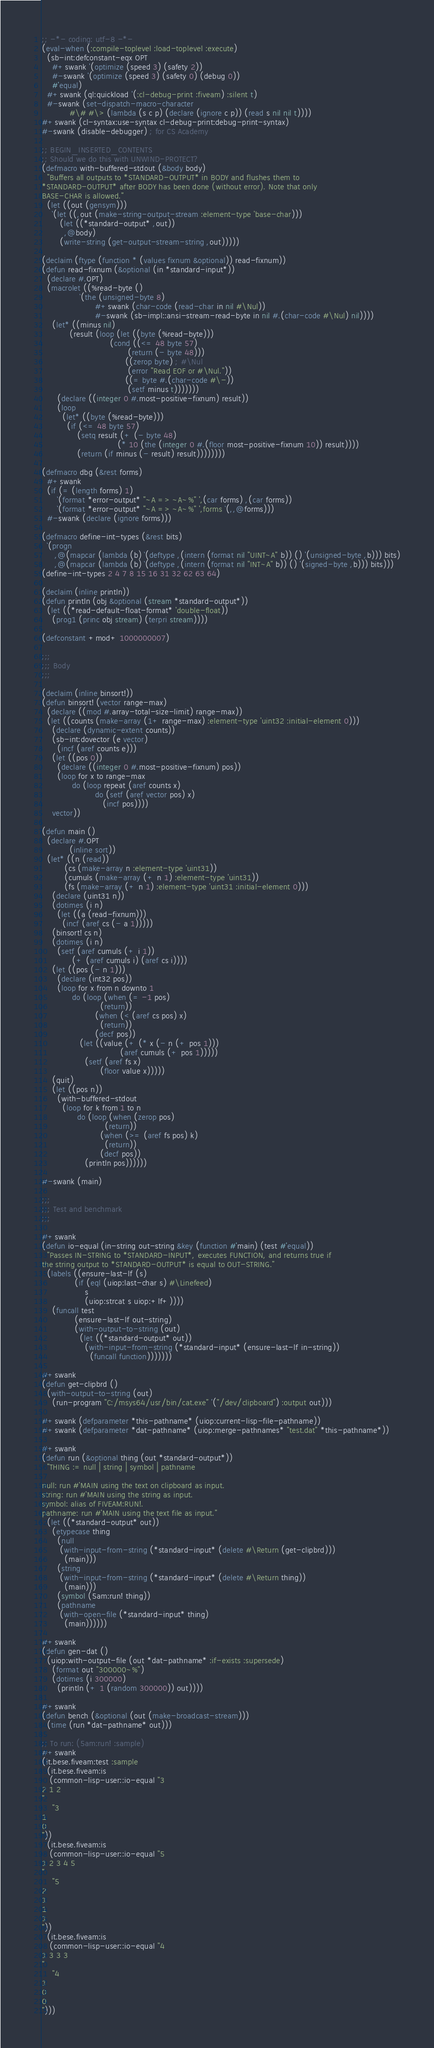Convert code to text. <code><loc_0><loc_0><loc_500><loc_500><_Lisp_>;; -*- coding: utf-8 -*-
(eval-when (:compile-toplevel :load-toplevel :execute)
  (sb-int:defconstant-eqx OPT
    #+swank '(optimize (speed 3) (safety 2))
    #-swank '(optimize (speed 3) (safety 0) (debug 0))
    #'equal)
  #+swank (ql:quickload '(:cl-debug-print :fiveam) :silent t)
  #-swank (set-dispatch-macro-character
           #\# #\> (lambda (s c p) (declare (ignore c p)) (read s nil nil t))))
#+swank (cl-syntax:use-syntax cl-debug-print:debug-print-syntax)
#-swank (disable-debugger) ; for CS Academy

;; BEGIN_INSERTED_CONTENTS
;; Should we do this with UNWIND-PROTECT?
(defmacro with-buffered-stdout (&body body)
  "Buffers all outputs to *STANDARD-OUTPUT* in BODY and flushes them to
*STANDARD-OUTPUT* after BODY has been done (without error). Note that only
BASE-CHAR is allowed."
  (let ((out (gensym)))
    `(let ((,out (make-string-output-stream :element-type 'base-char)))
       (let ((*standard-output* ,out))
         ,@body)
       (write-string (get-output-stream-string ,out)))))

(declaim (ftype (function * (values fixnum &optional)) read-fixnum))
(defun read-fixnum (&optional (in *standard-input*))
  (declare #.OPT)
  (macrolet ((%read-byte ()
               `(the (unsigned-byte 8)
                     #+swank (char-code (read-char in nil #\Nul))
                     #-swank (sb-impl::ansi-stream-read-byte in nil #.(char-code #\Nul) nil))))
    (let* ((minus nil)
           (result (loop (let ((byte (%read-byte)))
                           (cond ((<= 48 byte 57)
                                  (return (- byte 48)))
                                 ((zerop byte) ; #\Nul
                                  (error "Read EOF or #\Nul."))
                                 ((= byte #.(char-code #\-))
                                  (setf minus t)))))))
      (declare ((integer 0 #.most-positive-fixnum) result))
      (loop
        (let* ((byte (%read-byte)))
          (if (<= 48 byte 57)
              (setq result (+ (- byte 48)
                              (* 10 (the (integer 0 #.(floor most-positive-fixnum 10)) result))))
              (return (if minus (- result) result))))))))

(defmacro dbg (&rest forms)
  #+swank
  (if (= (length forms) 1)
      `(format *error-output* "~A => ~A~%" ',(car forms) ,(car forms))
      `(format *error-output* "~A => ~A~%" ',forms `(,,@forms)))
  #-swank (declare (ignore forms)))

(defmacro define-int-types (&rest bits)
  `(progn
     ,@(mapcar (lambda (b) `(deftype ,(intern (format nil "UINT~A" b)) () '(unsigned-byte ,b))) bits)
     ,@(mapcar (lambda (b) `(deftype ,(intern (format nil "INT~A" b)) () '(signed-byte ,b))) bits)))
(define-int-types 2 4 7 8 15 16 31 32 62 63 64)

(declaim (inline println))
(defun println (obj &optional (stream *standard-output*))
  (let ((*read-default-float-format* 'double-float))
    (prog1 (princ obj stream) (terpri stream))))

(defconstant +mod+ 1000000007)

;;;
;;; Body
;;;

(declaim (inline binsort!))
(defun binsort! (vector range-max)
  (declare ((mod #.array-total-size-limit) range-max))
  (let ((counts (make-array (1+ range-max) :element-type 'uint32 :initial-element 0)))
    (declare (dynamic-extent counts))
    (sb-int:dovector (e vector)
      (incf (aref counts e)))
    (let ((pos 0))
      (declare ((integer 0 #.most-positive-fixnum) pos))
      (loop for x to range-max
            do (loop repeat (aref counts x)
                     do (setf (aref vector pos) x)
                        (incf pos))))
    vector))

(defun main ()
  (declare #.OPT
           (inline sort))
  (let* ((n (read))
         (cs (make-array n :element-type 'uint31))
         (cumuls (make-array (+ n 1) :element-type 'uint31))
         (fs (make-array (+ n 1) :element-type 'uint31 :initial-element 0)))
    (declare (uint31 n))
    (dotimes (i n)
      (let ((a (read-fixnum)))
        (incf (aref cs (- a 1)))))
    (binsort! cs n)
    (dotimes (i n)
      (setf (aref cumuls (+ i 1))
            (+ (aref cumuls i) (aref cs i))))
    (let ((pos (- n 1)))
      (declare (int32 pos))
      (loop for x from n downto 1
            do (loop (when (= -1 pos)
                       (return))
                     (when (< (aref cs pos) x)
                       (return))
                     (decf pos))
               (let ((value (+ (* x (- n (+ pos 1)))
                               (aref cumuls (+ pos 1)))))
                 (setf (aref fs x)
                       (floor value x)))))
    (quit)
    (let ((pos n))
      (with-buffered-stdout
        (loop for k from 1 to n
              do (loop (when (zerop pos)
                         (return))
                       (when (>= (aref fs pos) k)
                         (return))
                       (decf pos))
                 (println pos))))))

#-swank (main)

;;;
;;; Test and benchmark
;;;

#+swank
(defun io-equal (in-string out-string &key (function #'main) (test #'equal))
  "Passes IN-STRING to *STANDARD-INPUT*, executes FUNCTION, and returns true if
the string output to *STANDARD-OUTPUT* is equal to OUT-STRING."
  (labels ((ensure-last-lf (s)
             (if (eql (uiop:last-char s) #\Linefeed)
                 s
                 (uiop:strcat s uiop:+lf+))))
    (funcall test
             (ensure-last-lf out-string)
             (with-output-to-string (out)
               (let ((*standard-output* out))
                 (with-input-from-string (*standard-input* (ensure-last-lf in-string))
                   (funcall function)))))))

#+swank
(defun get-clipbrd ()
  (with-output-to-string (out)
    (run-program "C:/msys64/usr/bin/cat.exe" '("/dev/clipboard") :output out)))

#+swank (defparameter *this-pathname* (uiop:current-lisp-file-pathname))
#+swank (defparameter *dat-pathname* (uiop:merge-pathnames* "test.dat" *this-pathname*))

#+swank
(defun run (&optional thing (out *standard-output*))
  "THING := null | string | symbol | pathname

null: run #'MAIN using the text on clipboard as input.
string: run #'MAIN using the string as input.
symbol: alias of FIVEAM:RUN!.
pathname: run #'MAIN using the text file as input."
  (let ((*standard-output* out))
    (etypecase thing
      (null
       (with-input-from-string (*standard-input* (delete #\Return (get-clipbrd)))
         (main)))
      (string
       (with-input-from-string (*standard-input* (delete #\Return thing))
         (main)))
      (symbol (5am:run! thing))
      (pathname
       (with-open-file (*standard-input* thing)
         (main))))))

#+swank
(defun gen-dat ()
  (uiop:with-output-file (out *dat-pathname* :if-exists :supersede)
    (format out "300000~%")
    (dotimes (i 300000)
      (println (+ 1 (random 300000)) out))))

#+swank
(defun bench (&optional (out (make-broadcast-stream)))
  (time (run *dat-pathname* out)))

;; To run: (5am:run! :sample)
#+swank
(it.bese.fiveam:test :sample
  (it.bese.fiveam:is
   (common-lisp-user::io-equal "3
2 1 2
"
    "3
1
0
"))
  (it.bese.fiveam:is
   (common-lisp-user::io-equal "5
1 2 3 4 5
"
    "5
2
1
1
1
"))
  (it.bese.fiveam:is
   (common-lisp-user::io-equal "4
1 3 3 3
"
    "4
1
0
0
")))
</code> 